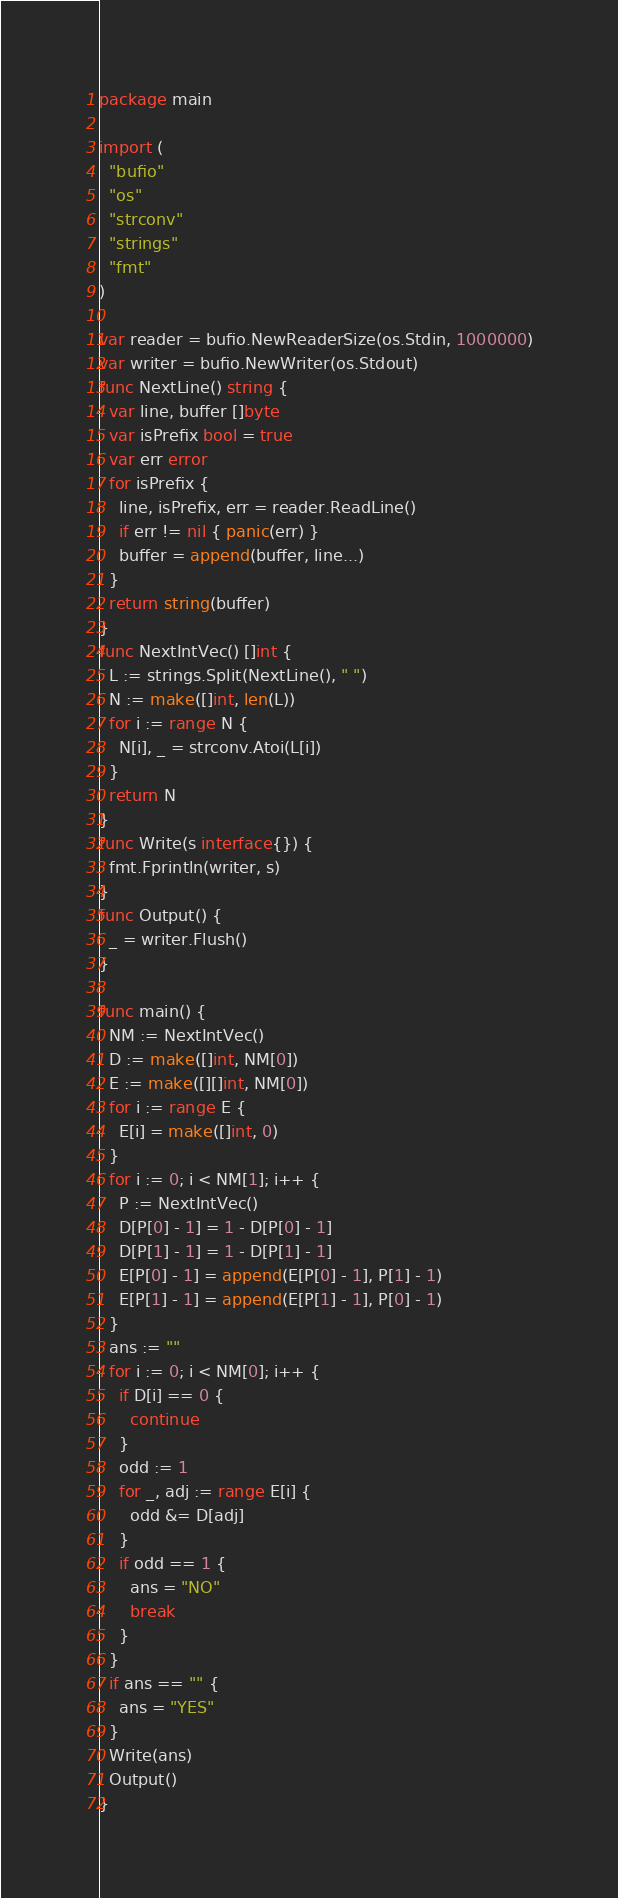Convert code to text. <code><loc_0><loc_0><loc_500><loc_500><_Go_>package main
 
import (
  "bufio"
  "os"
  "strconv"
  "strings"
  "fmt"
)
 
var reader = bufio.NewReaderSize(os.Stdin, 1000000)
var writer = bufio.NewWriter(os.Stdout)
func NextLine() string {
  var line, buffer []byte
  var isPrefix bool = true
  var err error
  for isPrefix {
    line, isPrefix, err = reader.ReadLine()
    if err != nil { panic(err) }
    buffer = append(buffer, line...)
  }
  return string(buffer)
}
func NextIntVec() []int {
  L := strings.Split(NextLine(), " ")
  N := make([]int, len(L))
  for i := range N {
    N[i], _ = strconv.Atoi(L[i])
  }
  return N
}
func Write(s interface{}) {
  fmt.Fprintln(writer, s)
}
func Output() {
  _ = writer.Flush()
}

func main() {
  NM := NextIntVec()
  D := make([]int, NM[0])
  E := make([][]int, NM[0])
  for i := range E {
    E[i] = make([]int, 0)
  }
  for i := 0; i < NM[1]; i++ {
    P := NextIntVec()
    D[P[0] - 1] = 1 - D[P[0] - 1]
    D[P[1] - 1] = 1 - D[P[1] - 1]
    E[P[0] - 1] = append(E[P[0] - 1], P[1] - 1)
    E[P[1] - 1] = append(E[P[1] - 1], P[0] - 1)
  }
  ans := ""
  for i := 0; i < NM[0]; i++ {
    if D[i] == 0 {
      continue
    }
    odd := 1
    for _, adj := range E[i] {
      odd &= D[adj]
    }
    if odd == 1 {
      ans = "NO"
      break
    }
  }
  if ans == "" {
    ans = "YES"
  }
  Write(ans)
  Output()
}</code> 